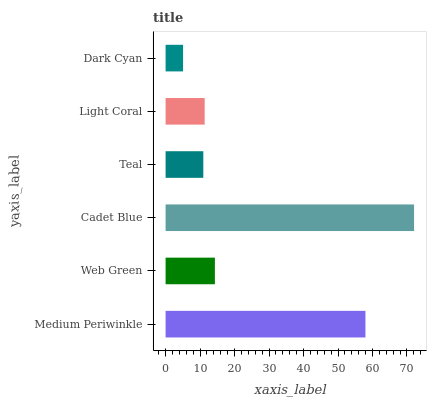Is Dark Cyan the minimum?
Answer yes or no. Yes. Is Cadet Blue the maximum?
Answer yes or no. Yes. Is Web Green the minimum?
Answer yes or no. No. Is Web Green the maximum?
Answer yes or no. No. Is Medium Periwinkle greater than Web Green?
Answer yes or no. Yes. Is Web Green less than Medium Periwinkle?
Answer yes or no. Yes. Is Web Green greater than Medium Periwinkle?
Answer yes or no. No. Is Medium Periwinkle less than Web Green?
Answer yes or no. No. Is Web Green the high median?
Answer yes or no. Yes. Is Light Coral the low median?
Answer yes or no. Yes. Is Dark Cyan the high median?
Answer yes or no. No. Is Teal the low median?
Answer yes or no. No. 